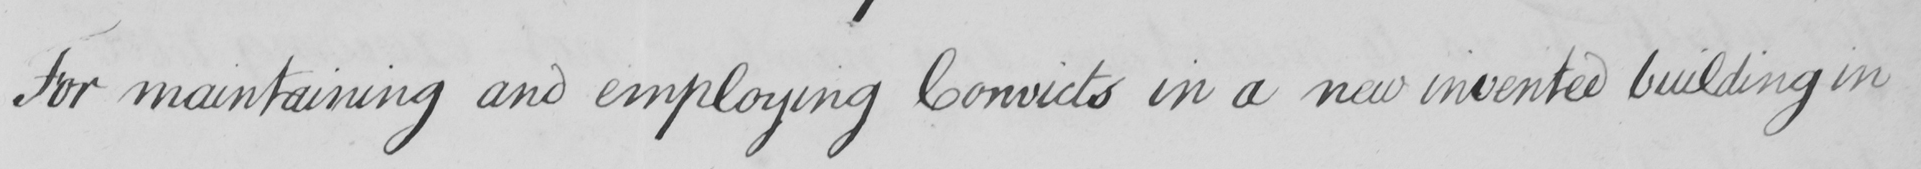What is written in this line of handwriting? For maintaining and employing Convicts in a new invented building in 